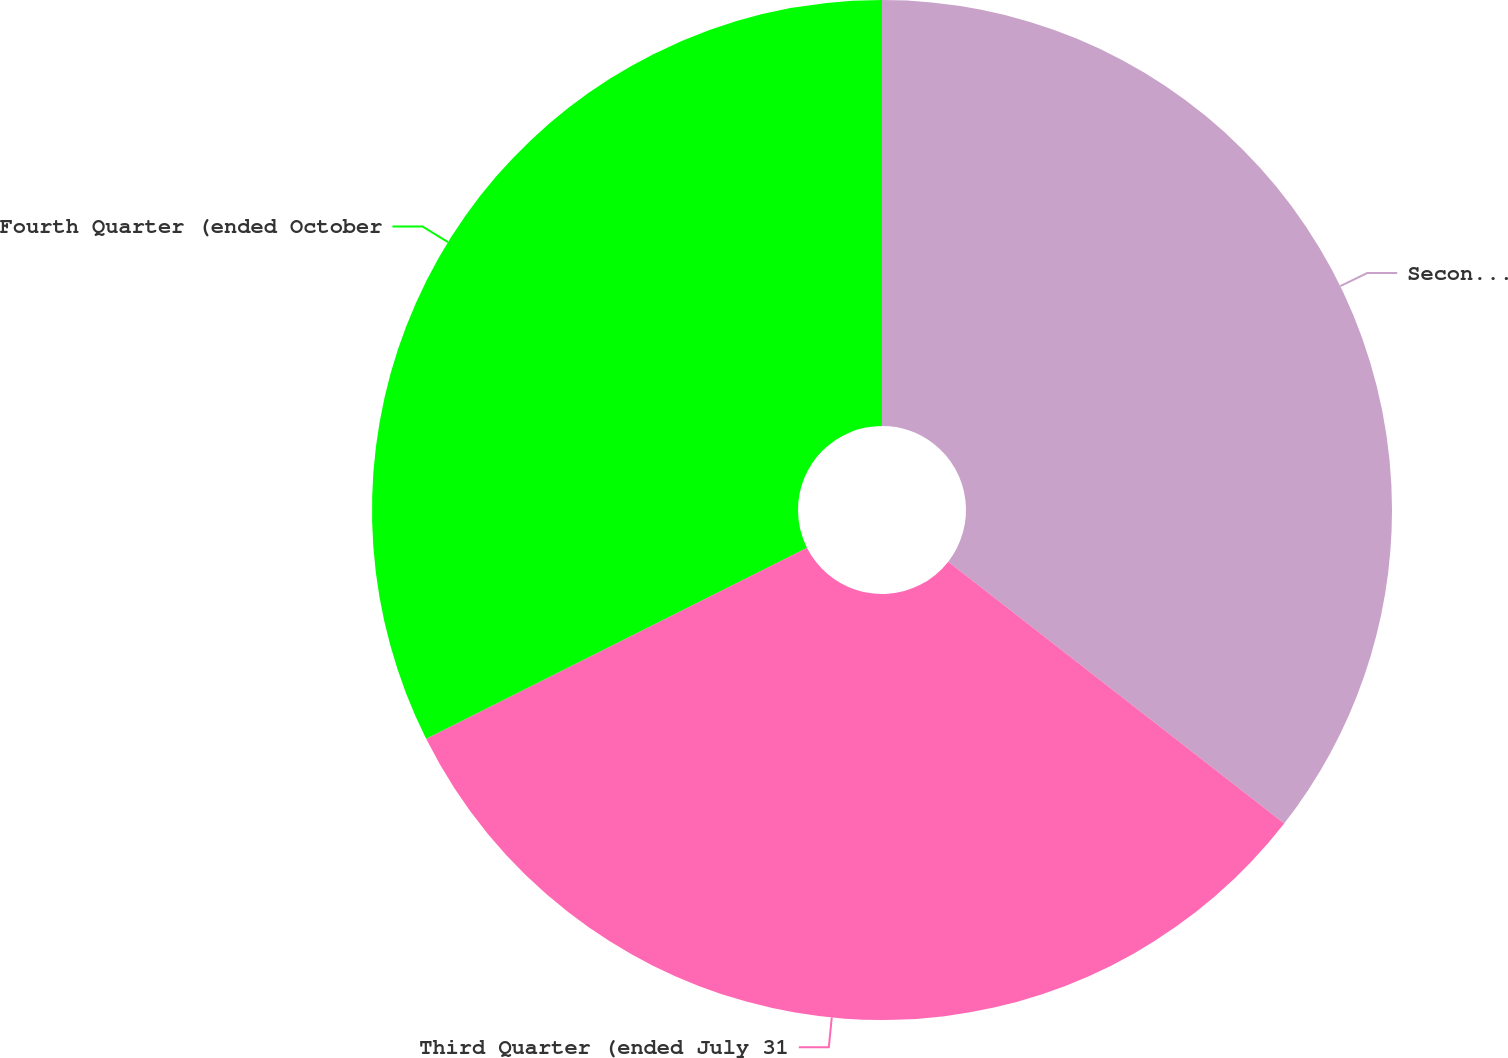Convert chart to OTSL. <chart><loc_0><loc_0><loc_500><loc_500><pie_chart><fcel>Second Quarter (ended April 30<fcel>Third Quarter (ended July 31<fcel>Fourth Quarter (ended October<nl><fcel>35.54%<fcel>32.06%<fcel>32.4%<nl></chart> 